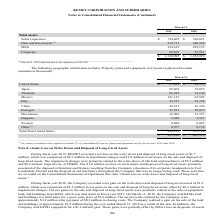From Kemet Corporation's financial document, Which years does the table provide information for total assets by reportable segment? The document shows two values: 2019 and 2018. From the document: "2019 2018 2019 2018..." Also, What were the total assets in MSA in 2019? According to the financial document, 234,419 (in thousands). The relevant text states: "MSA 234,419 254,193..." Also, What were the total Corporate assets in 2018? According to the financial document, 22,911 (in thousands). The relevant text states: "Corporate 69,563 22,911..." Also, can you calculate: What was the change in total assets in Solid Capacitors between 2018 and 2019? Based on the calculation: 794,402-704,851, the result is 89551 (in thousands). This is based on the information: "Solid Capacitors $ 794,402 $ 704,851 Solid Capacitors $ 794,402 $ 704,851..." The key data points involved are: 704,851, 794,402. Also, can you calculate: What was the change in total assets in MSA between 2018 and 2019? Based on the calculation: 234,419-254,193, the result is -19774 (in thousands). This is based on the information: "MSA 234,419 254,193 MSA 234,419 254,193..." The key data points involved are: 234,419, 254,193. Also, can you calculate: What was the percentage change total amount of assets across all segments between 2018 and 2019? To answer this question, I need to perform calculations using the financial data. The calculation is: (1,318,095-1,222,923)/1,222,923, which equals 7.78 (percentage). This is based on the information: "$ 1,318,095 $ 1,222,923 $ 1,318,095 $ 1,222,923..." The key data points involved are: 1,222,923, 1,318,095. 